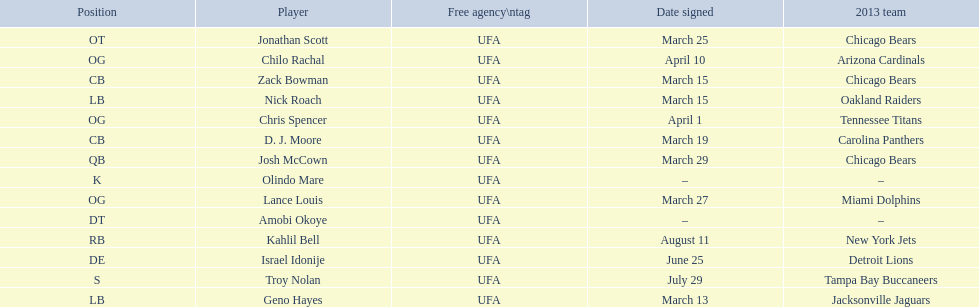Would you mind parsing the complete table? {'header': ['Position', 'Player', 'Free agency\\ntag', 'Date signed', '2013 team'], 'rows': [['OT', 'Jonathan Scott', 'UFA', 'March 25', 'Chicago Bears'], ['OG', 'Chilo Rachal', 'UFA', 'April 10', 'Arizona Cardinals'], ['CB', 'Zack Bowman', 'UFA', 'March 15', 'Chicago Bears'], ['LB', 'Nick Roach', 'UFA', 'March 15', 'Oakland Raiders'], ['OG', 'Chris Spencer', 'UFA', 'April 1', 'Tennessee Titans'], ['CB', 'D. J. Moore', 'UFA', 'March 19', 'Carolina Panthers'], ['QB', 'Josh McCown', 'UFA', 'March 29', 'Chicago Bears'], ['K', 'Olindo Mare', 'UFA', '–', '–'], ['OG', 'Lance Louis', 'UFA', 'March 27', 'Miami Dolphins'], ['DT', 'Amobi Okoye', 'UFA', '–', '–'], ['RB', 'Kahlil Bell', 'UFA', 'August 11', 'New York Jets'], ['DE', 'Israel Idonije', 'UFA', 'June 25', 'Detroit Lions'], ['S', 'Troy Nolan', 'UFA', 'July 29', 'Tampa Bay Buccaneers'], ['LB', 'Geno Hayes', 'UFA', 'March 13', 'Jacksonville Jaguars']]} The top played position according to this chart. OG. 